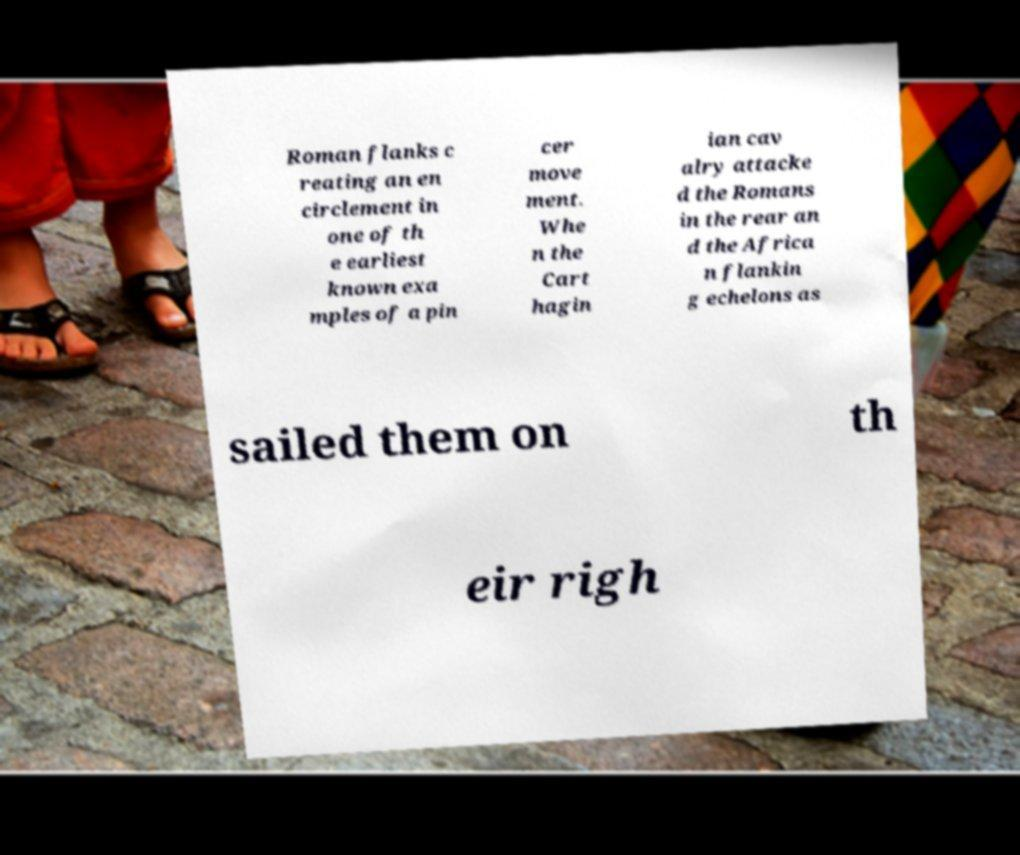Please identify and transcribe the text found in this image. Roman flanks c reating an en circlement in one of th e earliest known exa mples of a pin cer move ment. Whe n the Cart hagin ian cav alry attacke d the Romans in the rear an d the Africa n flankin g echelons as sailed them on th eir righ 